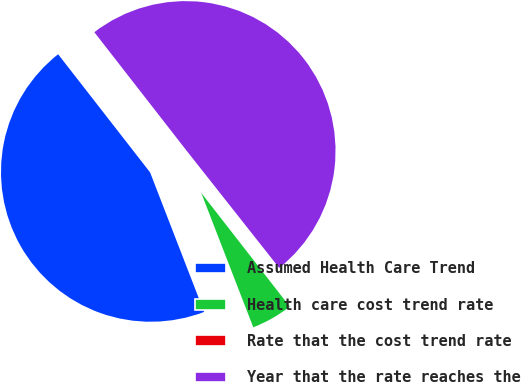<chart> <loc_0><loc_0><loc_500><loc_500><pie_chart><fcel>Assumed Health Care Trend<fcel>Health care cost trend rate<fcel>Rate that the cost trend rate<fcel>Year that the rate reaches the<nl><fcel>45.35%<fcel>4.65%<fcel>0.11%<fcel>49.89%<nl></chart> 